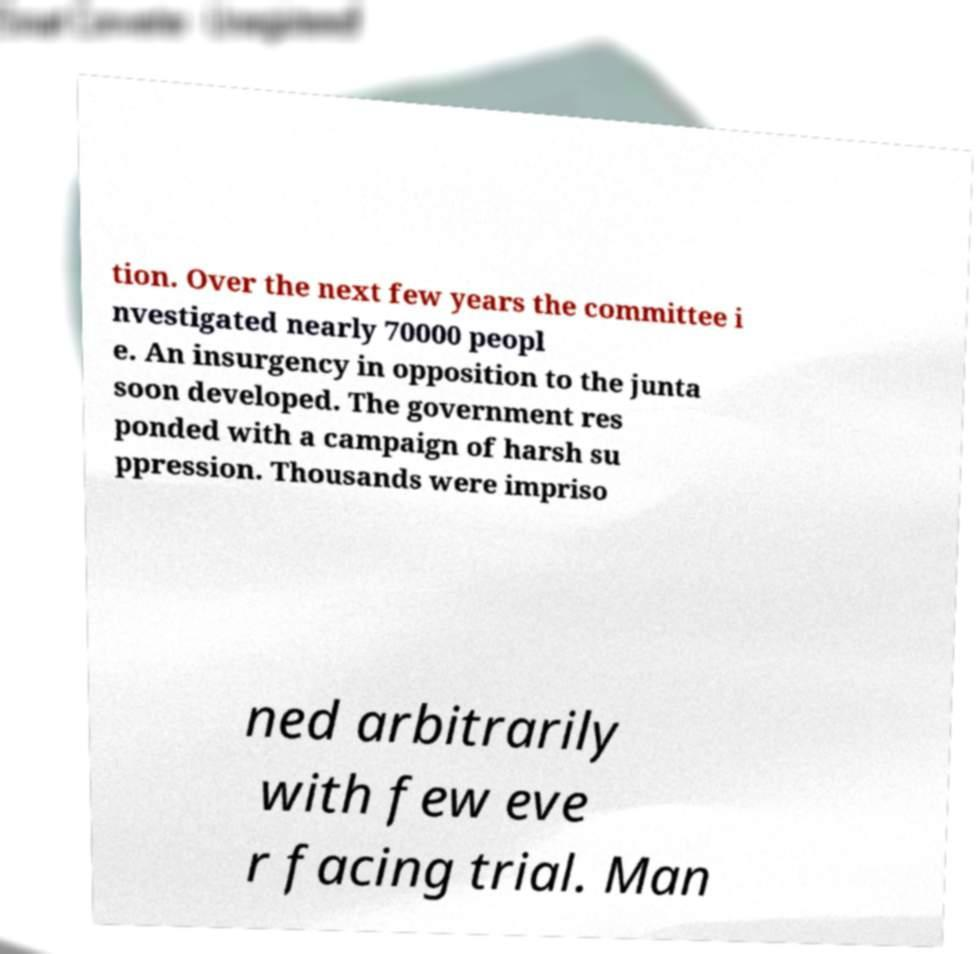Can you read and provide the text displayed in the image?This photo seems to have some interesting text. Can you extract and type it out for me? tion. Over the next few years the committee i nvestigated nearly 70000 peopl e. An insurgency in opposition to the junta soon developed. The government res ponded with a campaign of harsh su ppression. Thousands were impriso ned arbitrarily with few eve r facing trial. Man 